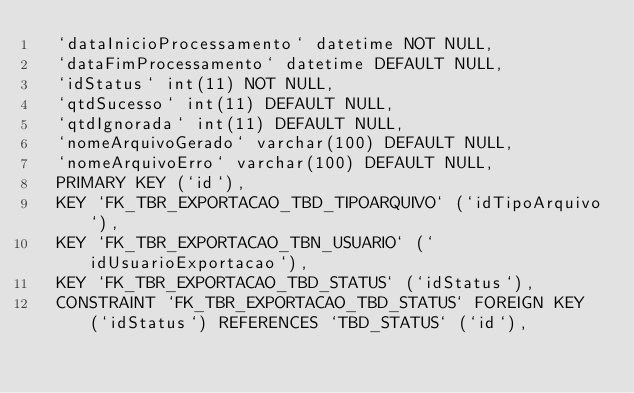Convert code to text. <code><loc_0><loc_0><loc_500><loc_500><_SQL_>  `dataInicioProcessamento` datetime NOT NULL,
  `dataFimProcessamento` datetime DEFAULT NULL,
  `idStatus` int(11) NOT NULL,
  `qtdSucesso` int(11) DEFAULT NULL,
  `qtdIgnorada` int(11) DEFAULT NULL,
  `nomeArquivoGerado` varchar(100) DEFAULT NULL,
  `nomeArquivoErro` varchar(100) DEFAULT NULL,
  PRIMARY KEY (`id`),
  KEY `FK_TBR_EXPORTACAO_TBD_TIPOARQUIVO` (`idTipoArquivo`),
  KEY `FK_TBR_EXPORTACAO_TBN_USUARIO` (`idUsuarioExportacao`),
  KEY `FK_TBR_EXPORTACAO_TBD_STATUS` (`idStatus`),
  CONSTRAINT `FK_TBR_EXPORTACAO_TBD_STATUS` FOREIGN KEY (`idStatus`) REFERENCES `TBD_STATUS` (`id`),</code> 